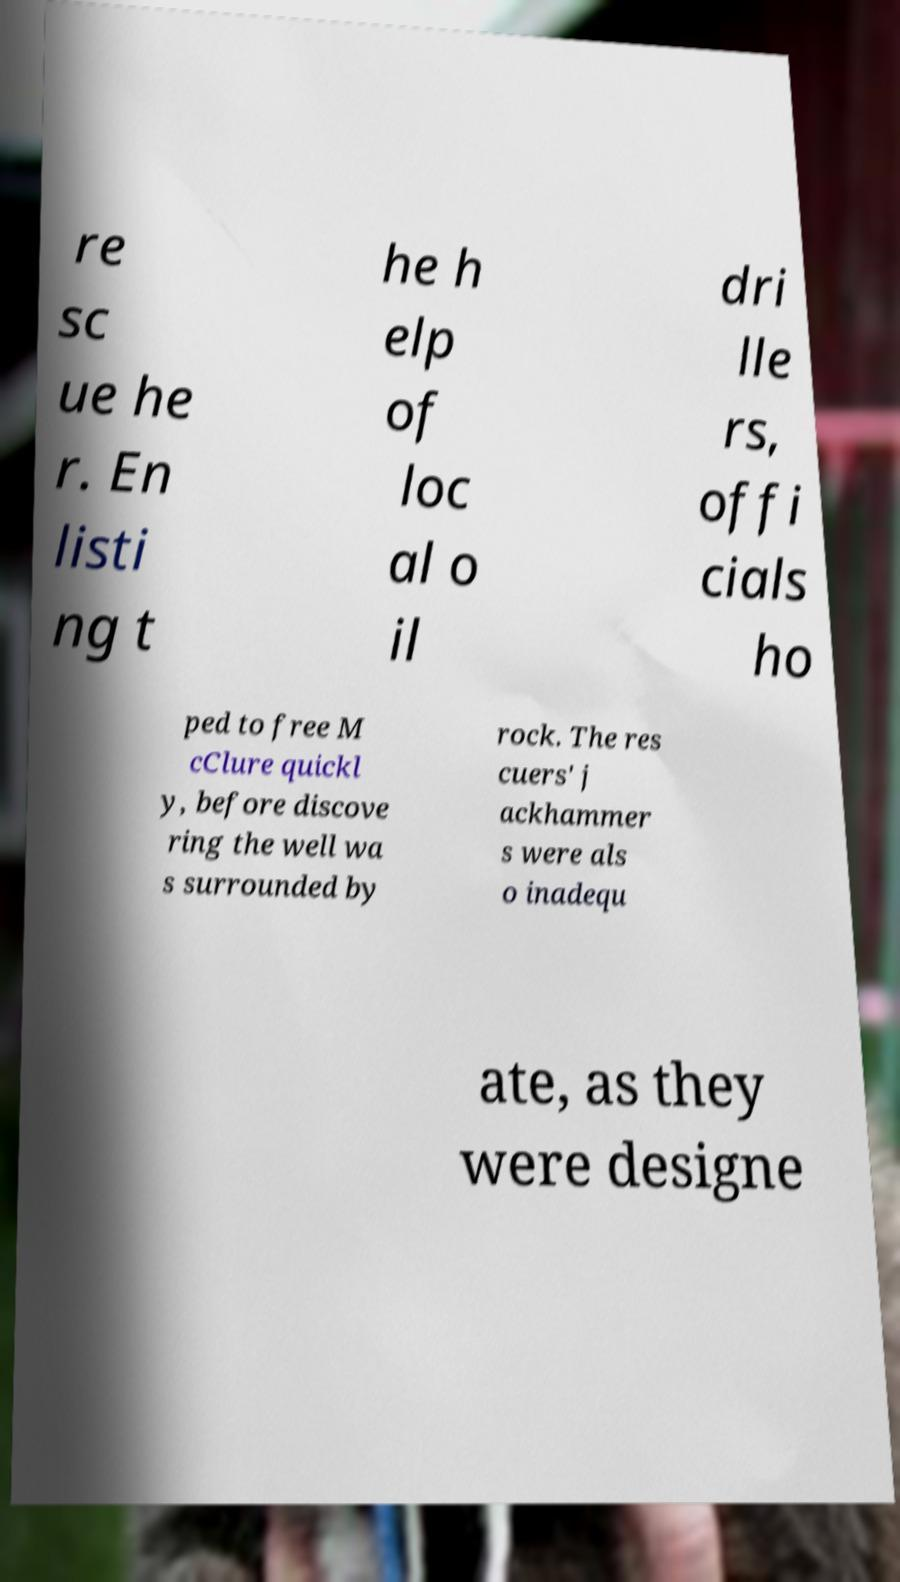Can you read and provide the text displayed in the image?This photo seems to have some interesting text. Can you extract and type it out for me? re sc ue he r. En listi ng t he h elp of loc al o il dri lle rs, offi cials ho ped to free M cClure quickl y, before discove ring the well wa s surrounded by rock. The res cuers' j ackhammer s were als o inadequ ate, as they were designe 